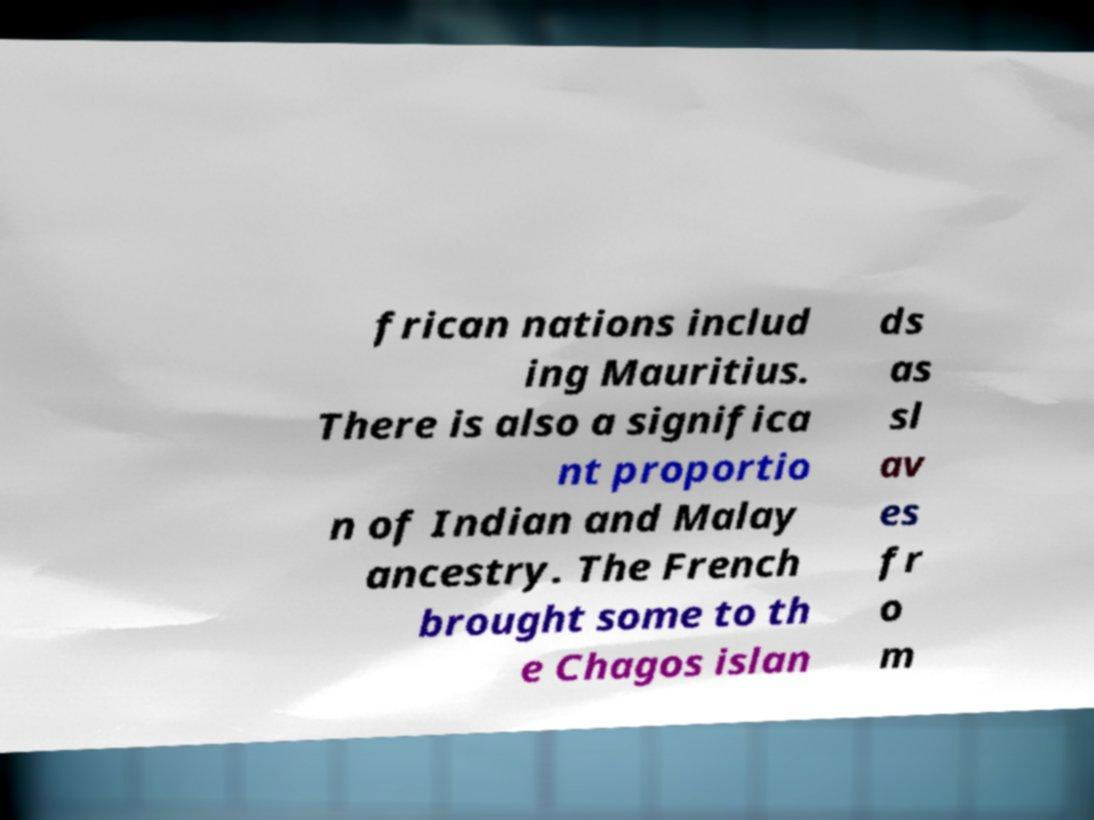Could you assist in decoding the text presented in this image and type it out clearly? frican nations includ ing Mauritius. There is also a significa nt proportio n of Indian and Malay ancestry. The French brought some to th e Chagos islan ds as sl av es fr o m 